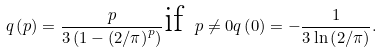Convert formula to latex. <formula><loc_0><loc_0><loc_500><loc_500>q \left ( p \right ) = \frac { p } { 3 \left ( 1 - \left ( 2 / \pi \right ) ^ { p } \right ) } \text {if } p \neq 0 q \left ( 0 \right ) = - \frac { 1 } { 3 \ln \left ( 2 / \pi \right ) } .</formula> 